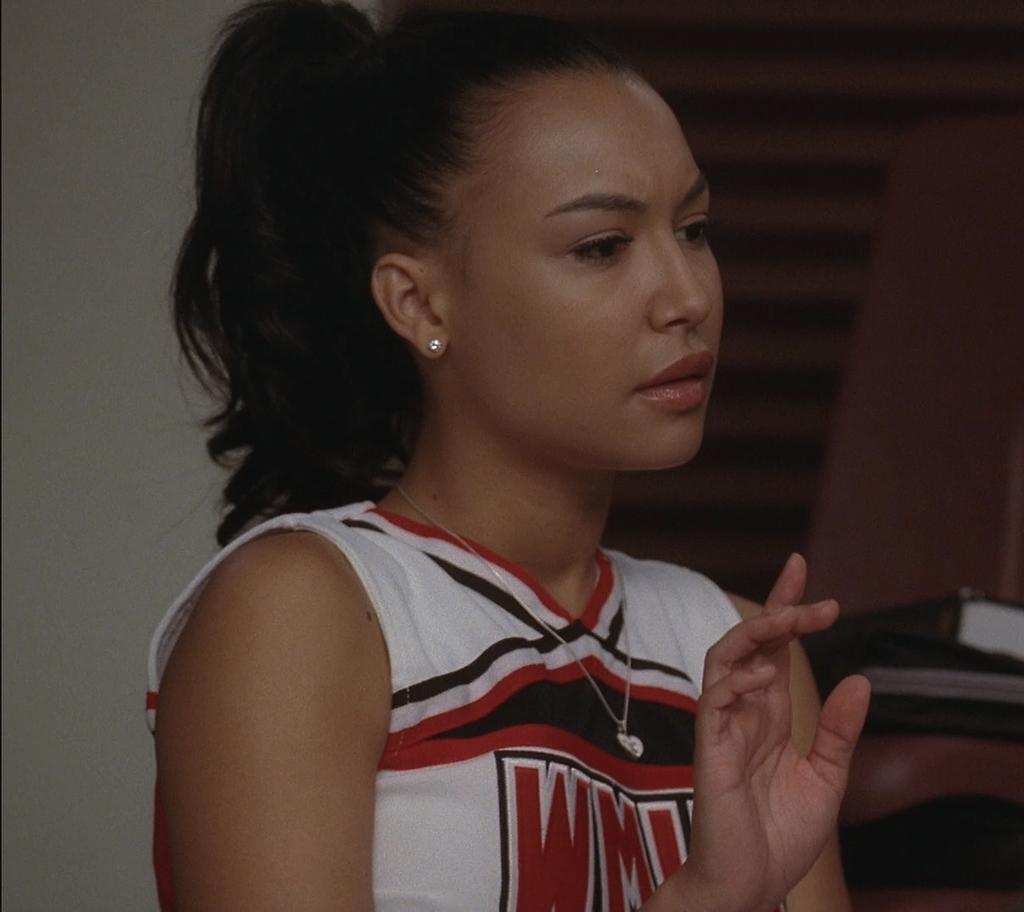<image>
Provide a brief description of the given image. A woman is wearing a cheerleader type shirt with a large w as the first letter. 